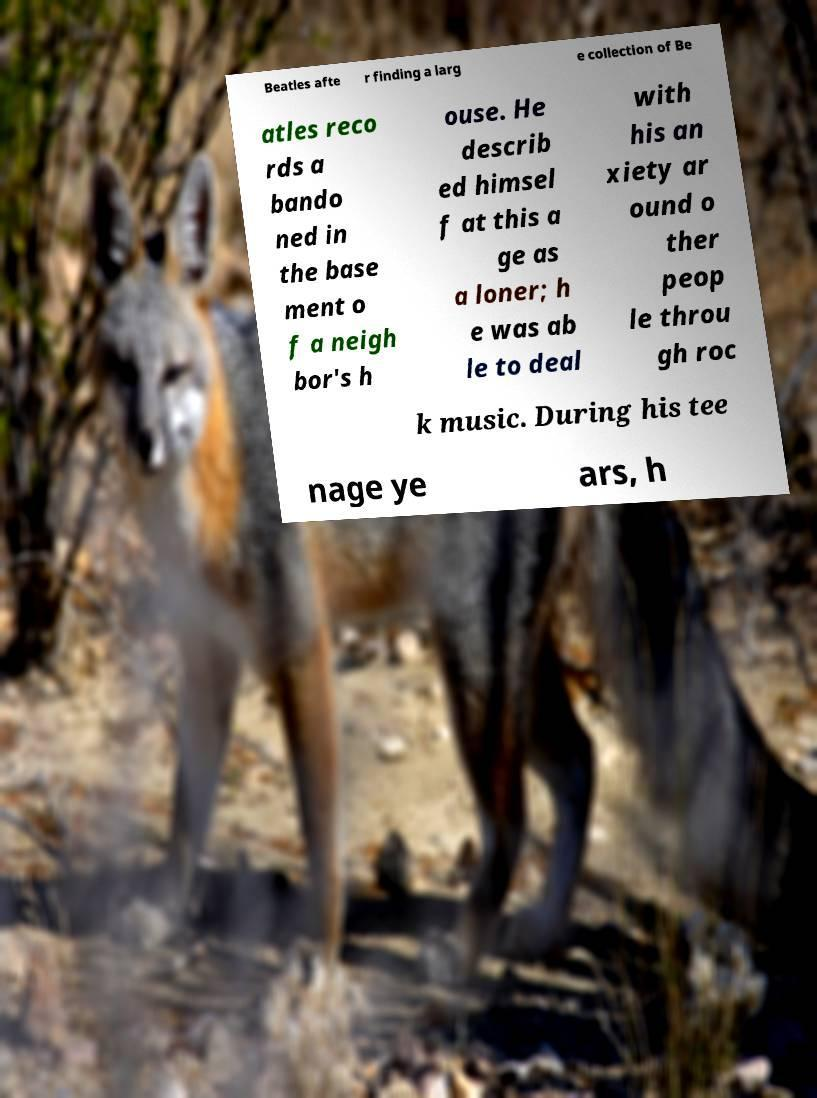Can you read and provide the text displayed in the image?This photo seems to have some interesting text. Can you extract and type it out for me? Beatles afte r finding a larg e collection of Be atles reco rds a bando ned in the base ment o f a neigh bor's h ouse. He describ ed himsel f at this a ge as a loner; h e was ab le to deal with his an xiety ar ound o ther peop le throu gh roc k music. During his tee nage ye ars, h 